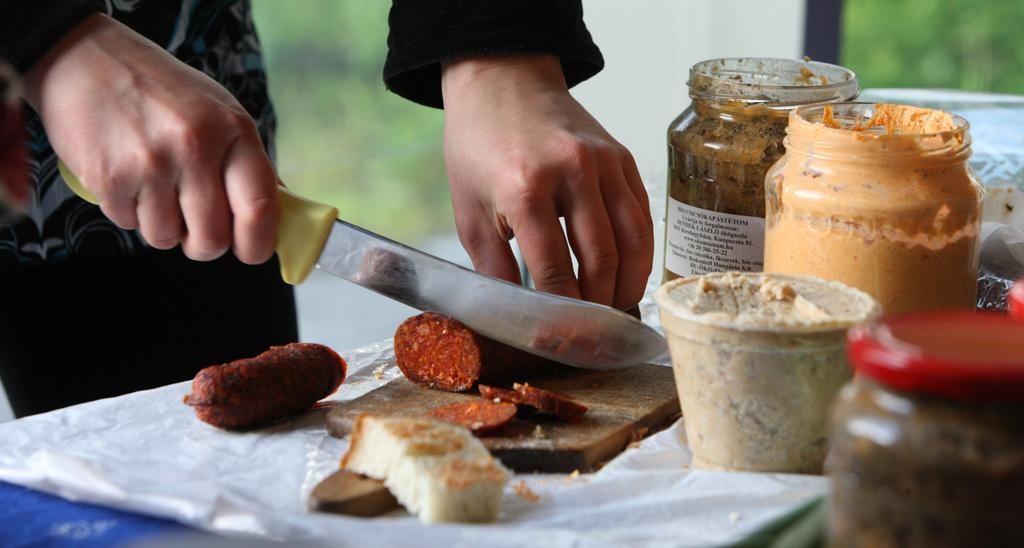How would you summarize this image in a sentence or two? In the image there is a person cutting food with knife on a chopping board, there are pickle bottles on the right side. 